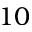<formula> <loc_0><loc_0><loc_500><loc_500>1 0</formula> 